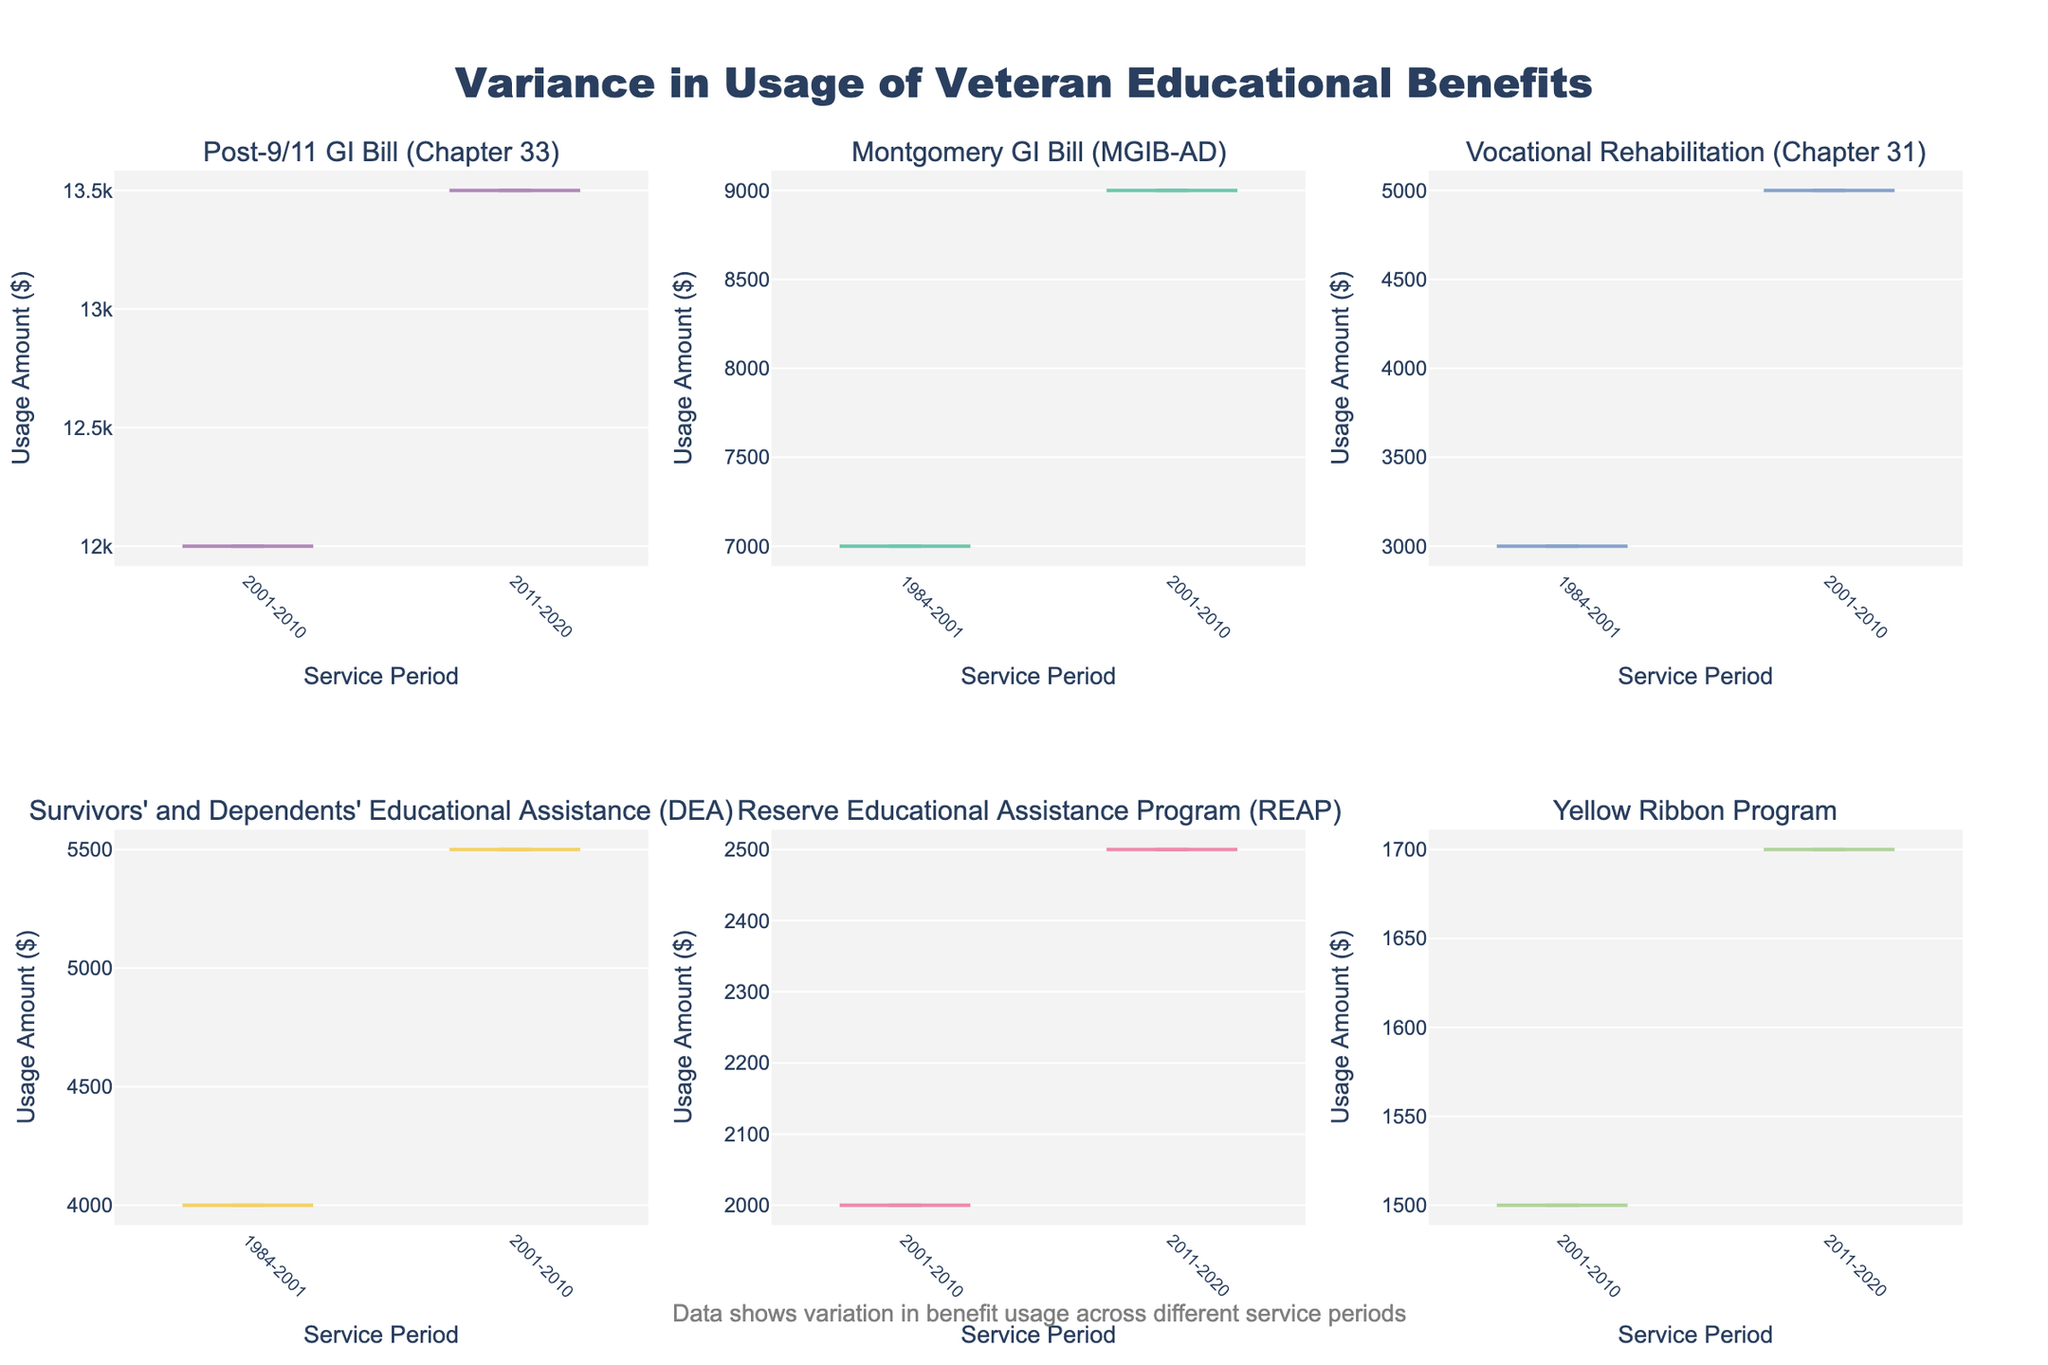What is the title of the figure? The title is often located at the top of the figure and summarizes what the plot represents. Reading the title can provide a quick insight into the main focus of the plot.
Answer: Variance in Usage of Veteran Educational Benefits How many different types of educational benefits are displayed in the figure? Count the number of unique subplot titles (benefit types) in the figure. Each violin chart represents a different type of benefit.
Answer: 6 Which educational benefit shows the highest average usage amount? Examine the position of the central peak (median line) of each violin chart. The highest central peak indicates the highest average usage amount.
Answer: Post-9/11 GI Bill (Chapter 33) During which service period was the usage amount for Montgomery GI Bill (MGIB-AD) lower? Compare the median line of the violin plots for the Montgomery GI Bill (MGIB-AD) across different service periods. The lower position of the median line indicates lower usage.
Answer: 1984-2001 Which educational benefit shows the highest variation in usage amounts during 2001-2010? Look for the widest spread of the data points (thicker violin plot) during the 2001-2010 service period for each benefit type. The more spread-out the data, the higher the variation.
Answer: Montgomery GI Bill (MGIB-AD) Which benefit type has the lowest median usage amount in 2011-2020? Locate the median lines (central peaks) on the violin plots for the 2011-2020 service period. The benefit type with the lowest median line has the lowest median usage amount.
Answer: Yellow Ribbon Program Is the usage amount for Vocational Rehabilitation (Chapter 31) higher in 1984-2001 or 2001-2010? Compare the median lines of the violin plots for Vocational Rehabilitation (Chapter 31) across the two service periods. The higher median line indicates a higher usage amount.
Answer: 2001-2010 How does the usage amount for Survivors' and Dependents' Educational Assistance (DEA) in 1984-2001 compare to that in 2001-2010? Compare the median lines and the spread (thickness) of the violin plots for Survivors' and Dependents' Educational Assistance (DEA) between the two service periods.
Answer: Higher in 2001-2010 Is there any trend observable regarding the usage amount of the Yellow Ribbon Program across the service periods? Observe the median lines and the spread of the violin plots for the Yellow Ribbon Program in both service periods to note any changes in the usage amount.
Answer: Yes, it slightly increases 